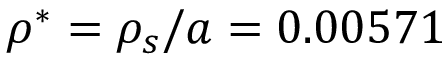Convert formula to latex. <formula><loc_0><loc_0><loc_500><loc_500>\rho ^ { * } = \rho _ { s } / a = 0 . 0 0 5 7 1</formula> 